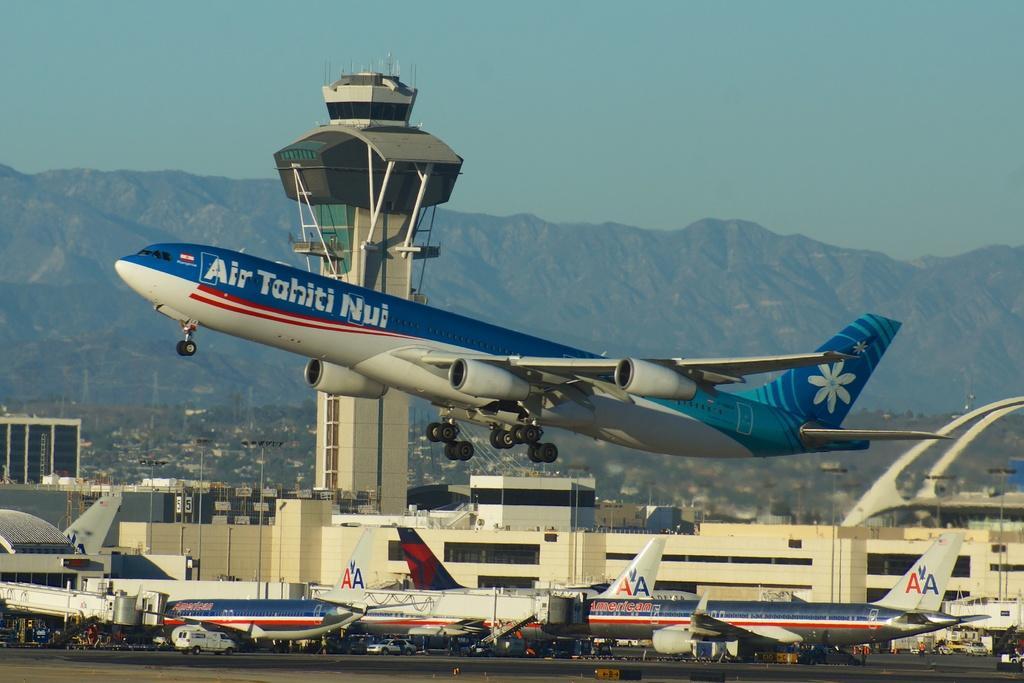Can you describe this image briefly? In this picture we can see there is an airplane flying in the air and on the path there are some airplanes and vehicles. Behind the airplanes there is a tower, buildings, poles, hills and a sky. 